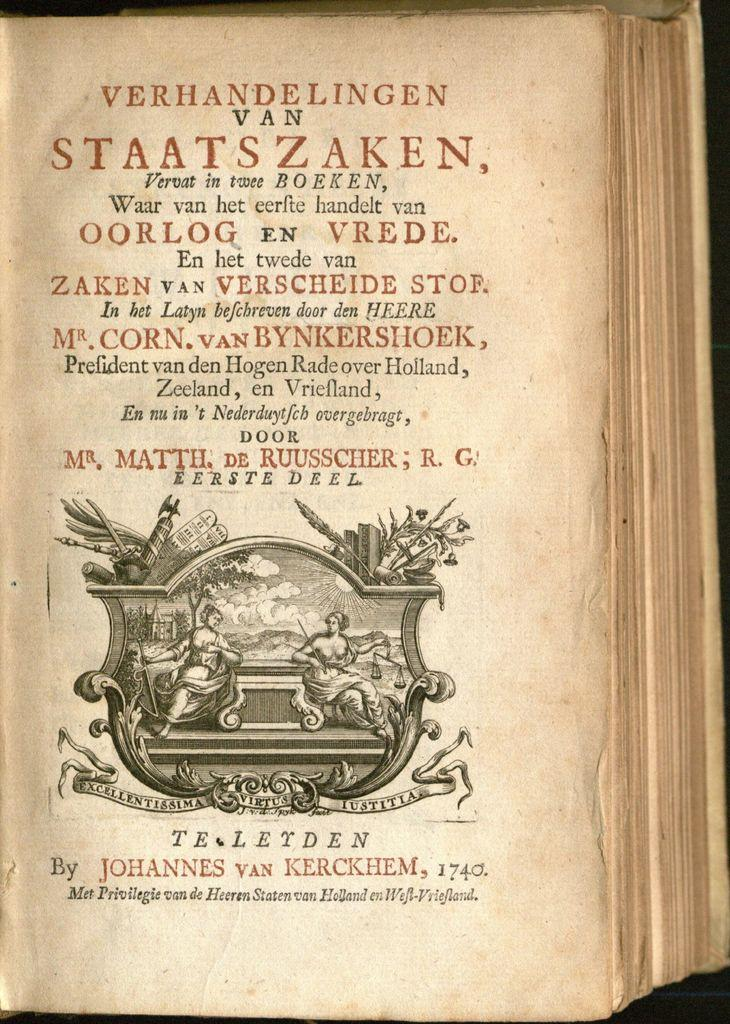<image>
Share a concise interpretation of the image provided. an old book open to the words verhandelingen van staatszaken 